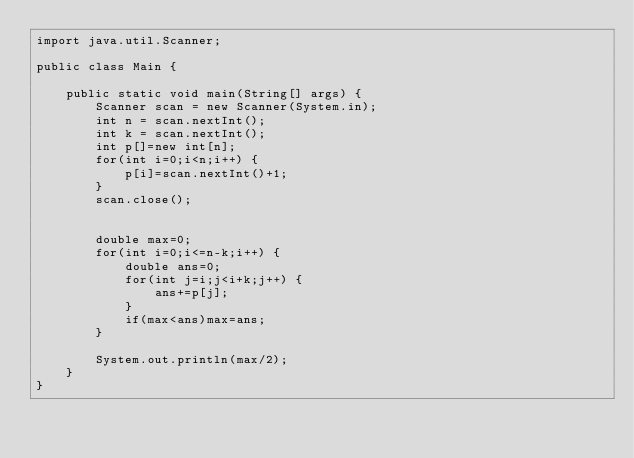<code> <loc_0><loc_0><loc_500><loc_500><_Java_>import java.util.Scanner;

public class Main {

	public static void main(String[] args) {
		Scanner scan = new Scanner(System.in);
		int n = scan.nextInt();
		int k = scan.nextInt();
		int p[]=new int[n];
		for(int i=0;i<n;i++) {
			p[i]=scan.nextInt()+1;
		}
		scan.close();


		double max=0;
		for(int i=0;i<=n-k;i++) {
			double ans=0;
			for(int j=i;j<i+k;j++) {
				ans+=p[j];
			}
			if(max<ans)max=ans;
		}

		System.out.println(max/2);
	}
}</code> 